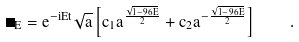Convert formula to latex. <formula><loc_0><loc_0><loc_500><loc_500>\Psi _ { E } = e ^ { - i E t } \sqrt { a } \left [ c _ { 1 } a ^ { \frac { \sqrt { 1 - 9 6 E } } { 2 } } + c _ { 2 } a ^ { - \frac { \sqrt { 1 - 9 6 E } } { 2 } } \right ] \quad .</formula> 